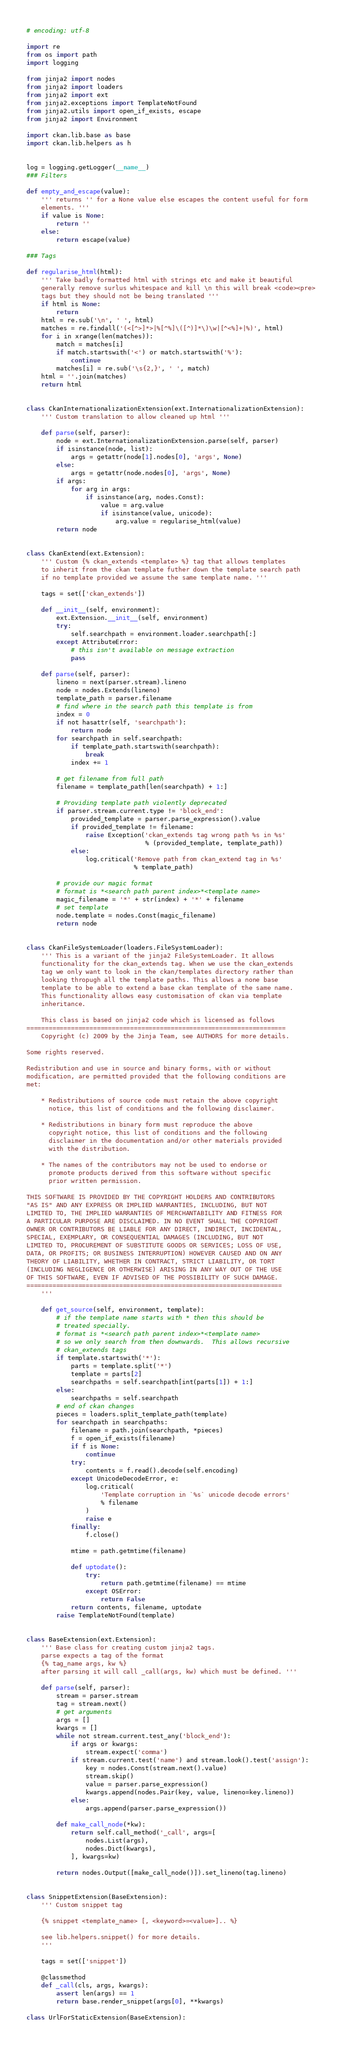<code> <loc_0><loc_0><loc_500><loc_500><_Python_># encoding: utf-8

import re
from os import path
import logging

from jinja2 import nodes
from jinja2 import loaders
from jinja2 import ext
from jinja2.exceptions import TemplateNotFound
from jinja2.utils import open_if_exists, escape
from jinja2 import Environment

import ckan.lib.base as base
import ckan.lib.helpers as h


log = logging.getLogger(__name__)
### Filters

def empty_and_escape(value):
    ''' returns '' for a None value else escapes the content useful for form
    elements. '''
    if value is None:
        return ''
    else:
        return escape(value)

### Tags

def regularise_html(html):
    ''' Take badly formatted html with strings etc and make it beautiful
    generally remove surlus whitespace and kill \n this will break <code><pre>
    tags but they should not be being translated '''
    if html is None:
        return
    html = re.sub('\n', ' ', html)
    matches = re.findall('(<[^>]*>|%[^%]\([^)]*\)\w|[^<%]+|%)', html)
    for i in xrange(len(matches)):
        match = matches[i]
        if match.startswith('<') or match.startswith('%'):
            continue
        matches[i] = re.sub('\s{2,}', ' ', match)
    html = ''.join(matches)
    return html


class CkanInternationalizationExtension(ext.InternationalizationExtension):
    ''' Custom translation to allow cleaned up html '''

    def parse(self, parser):
        node = ext.InternationalizationExtension.parse(self, parser)
        if isinstance(node, list):
            args = getattr(node[1].nodes[0], 'args', None)
        else:
            args = getattr(node.nodes[0], 'args', None)
        if args:
            for arg in args:
                if isinstance(arg, nodes.Const):
                    value = arg.value
                    if isinstance(value, unicode):
                        arg.value = regularise_html(value)
        return node


class CkanExtend(ext.Extension):
    ''' Custom {% ckan_extends <template> %} tag that allows templates
    to inherit from the ckan template futher down the template search path
    if no template provided we assume the same template name. '''

    tags = set(['ckan_extends'])

    def __init__(self, environment):
        ext.Extension.__init__(self, environment)
        try:
            self.searchpath = environment.loader.searchpath[:]
        except AttributeError:
            # this isn't available on message extraction
            pass

    def parse(self, parser):
        lineno = next(parser.stream).lineno
        node = nodes.Extends(lineno)
        template_path = parser.filename
        # find where in the search path this template is from
        index = 0
        if not hasattr(self, 'searchpath'):
            return node
        for searchpath in self.searchpath:
            if template_path.startswith(searchpath):
                break
            index += 1

        # get filename from full path
        filename = template_path[len(searchpath) + 1:]

        # Providing template path violently deprecated
        if parser.stream.current.type != 'block_end':
            provided_template = parser.parse_expression().value
            if provided_template != filename:
                raise Exception('ckan_extends tag wrong path %s in %s'
                                % (provided_template, template_path))
            else:
                log.critical('Remove path from ckan_extend tag in %s'
                             % template_path)

        # provide our magic format
        # format is *<search path parent index>*<template name>
        magic_filename = '*' + str(index) + '*' + filename
        # set template
        node.template = nodes.Const(magic_filename)
        return node


class CkanFileSystemLoader(loaders.FileSystemLoader):
    ''' This is a variant of the jinja2 FileSystemLoader. It allows
    functionality for the ckan_extends tag. When we use the ckan_extends
    tag we only want to look in the ckan/templates directory rather than
    looking thropugh all the template paths. This allows a none base
    template to be able to extend a base ckan template of the same name.
    This functionality allows easy customisation of ckan via template
    inheritance.

    This class is based on jinja2 code which is licensed as follows
======================================================================
    Copyright (c) 2009 by the Jinja Team, see AUTHORS for more details.

Some rights reserved.

Redistribution and use in source and binary forms, with or without
modification, are permitted provided that the following conditions are
met:

    * Redistributions of source code must retain the above copyright
      notice, this list of conditions and the following disclaimer.

    * Redistributions in binary form must reproduce the above
      copyright notice, this list of conditions and the following
      disclaimer in the documentation and/or other materials provided
      with the distribution.

    * The names of the contributors may not be used to endorse or
      promote products derived from this software without specific
      prior written permission.

THIS SOFTWARE IS PROVIDED BY THE COPYRIGHT HOLDERS AND CONTRIBUTORS
"AS IS" AND ANY EXPRESS OR IMPLIED WARRANTIES, INCLUDING, BUT NOT
LIMITED TO, THE IMPLIED WARRANTIES OF MERCHANTABILITY AND FITNESS FOR
A PARTICULAR PURPOSE ARE DISCLAIMED. IN NO EVENT SHALL THE COPYRIGHT
OWNER OR CONTRIBUTORS BE LIABLE FOR ANY DIRECT, INDIRECT, INCIDENTAL,
SPECIAL, EXEMPLARY, OR CONSEQUENTIAL DAMAGES (INCLUDING, BUT NOT
LIMITED TO, PROCUREMENT OF SUBSTITUTE GOODS OR SERVICES; LOSS OF USE,
DATA, OR PROFITS; OR BUSINESS INTERRUPTION) HOWEVER CAUSED AND ON ANY
THEORY OF LIABILITY, WHETHER IN CONTRACT, STRICT LIABILITY, OR TORT
(INCLUDING NEGLIGENCE OR OTHERWISE) ARISING IN ANY WAY OUT OF THE USE
OF THIS SOFTWARE, EVEN IF ADVISED OF THE POSSIBILITY OF SUCH DAMAGE.
=====================================================================
    '''

    def get_source(self, environment, template):
        # if the template name starts with * then this should be
        # treated specially.
        # format is *<search path parent index>*<template name>
        # so we only search from then downwards.  This allows recursive
        # ckan_extends tags
        if template.startswith('*'):
            parts = template.split('*')
            template = parts[2]
            searchpaths = self.searchpath[int(parts[1]) + 1:]
        else:
            searchpaths = self.searchpath
        # end of ckan changes
        pieces = loaders.split_template_path(template)
        for searchpath in searchpaths:
            filename = path.join(searchpath, *pieces)
            f = open_if_exists(filename)
            if f is None:
                continue
            try:
                contents = f.read().decode(self.encoding)
            except UnicodeDecodeError, e:
                log.critical(
                    'Template corruption in `%s` unicode decode errors'
                    % filename
                )
                raise e
            finally:
                f.close()

            mtime = path.getmtime(filename)

            def uptodate():
                try:
                    return path.getmtime(filename) == mtime
                except OSError:
                    return False
            return contents, filename, uptodate
        raise TemplateNotFound(template)


class BaseExtension(ext.Extension):
    ''' Base class for creating custom jinja2 tags.
    parse expects a tag of the format
    {% tag_name args, kw %}
    after parsing it will call _call(args, kw) which must be defined. '''

    def parse(self, parser):
        stream = parser.stream
        tag = stream.next()
        # get arguments
        args = []
        kwargs = []
        while not stream.current.test_any('block_end'):
            if args or kwargs:
                stream.expect('comma')
            if stream.current.test('name') and stream.look().test('assign'):
                key = nodes.Const(stream.next().value)
                stream.skip()
                value = parser.parse_expression()
                kwargs.append(nodes.Pair(key, value, lineno=key.lineno))
            else:
                args.append(parser.parse_expression())

        def make_call_node(*kw):
            return self.call_method('_call', args=[
                nodes.List(args),
                nodes.Dict(kwargs),
            ], kwargs=kw)

        return nodes.Output([make_call_node()]).set_lineno(tag.lineno)


class SnippetExtension(BaseExtension):
    ''' Custom snippet tag

    {% snippet <template_name> [, <keyword>=<value>].. %}

    see lib.helpers.snippet() for more details.
    '''

    tags = set(['snippet'])

    @classmethod
    def _call(cls, args, kwargs):
        assert len(args) == 1
        return base.render_snippet(args[0], **kwargs)

class UrlForStaticExtension(BaseExtension):</code> 